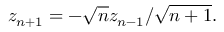Convert formula to latex. <formula><loc_0><loc_0><loc_500><loc_500>z _ { n + 1 } = - \sqrt { n } z _ { n - 1 } / \sqrt { n + 1 } .</formula> 